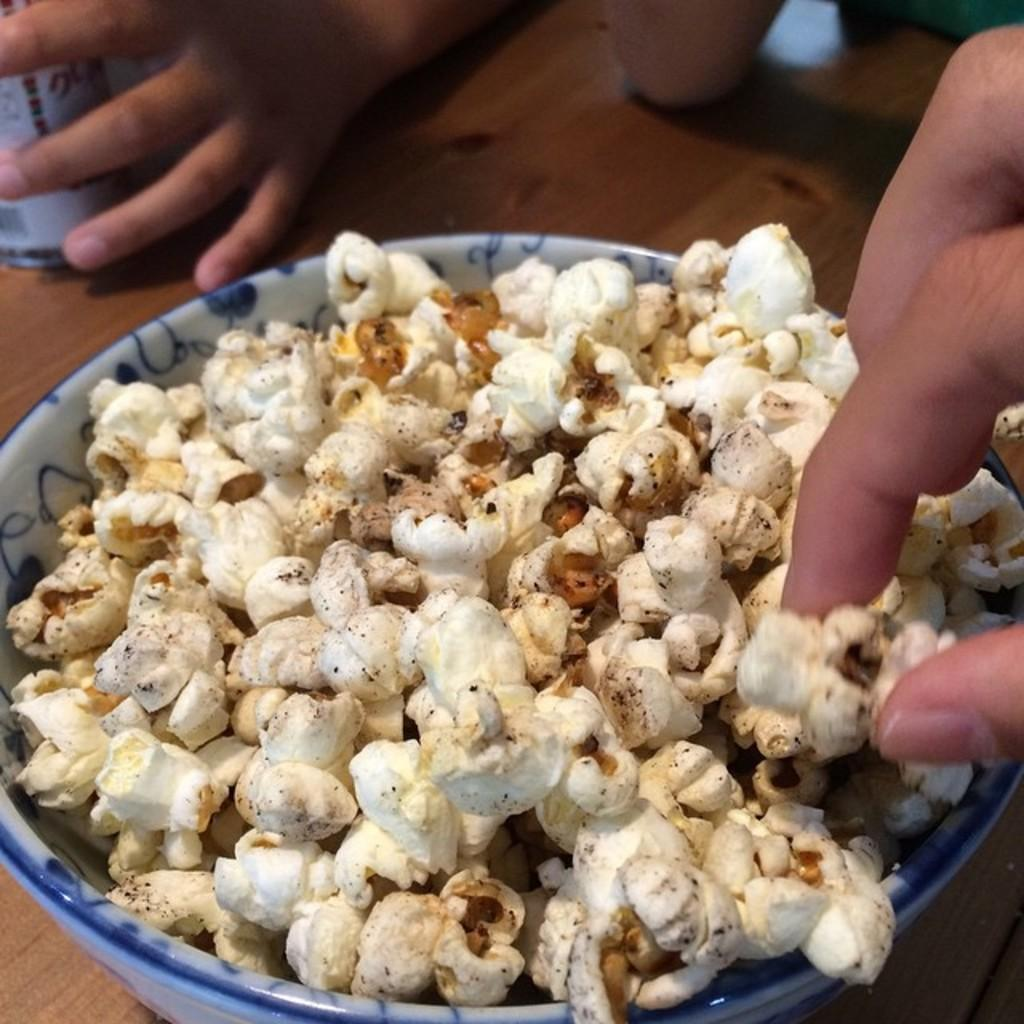What type of food is in the bowl that is visible in the image? There is a bowl of popcorn in the image. What else can be seen on the table in the image? There is an object on the table in the image. Can you describe the hands of people visible in the image? Hands of people are visible in the image. What type of copy machine is visible in the image? There is no copy machine present in the image. How many pickles are on the table in the image? There are no pickles present in the image. 